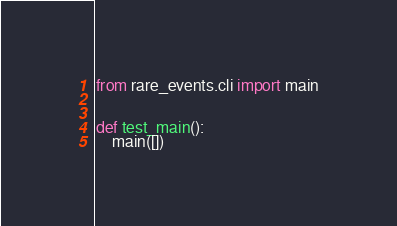Convert code to text. <code><loc_0><loc_0><loc_500><loc_500><_Python_>from rare_events.cli import main


def test_main():
    main([])
</code> 